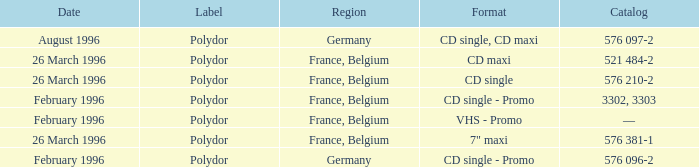Tell me the region for catalog of 576 096-2 Germany. 